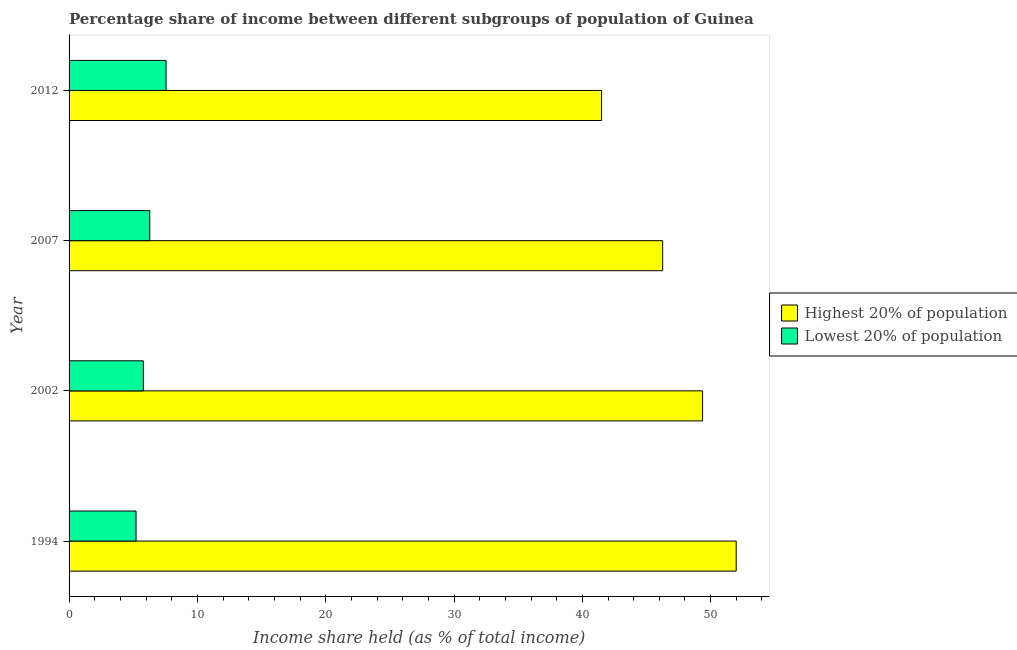How many groups of bars are there?
Ensure brevity in your answer.  4. Are the number of bars per tick equal to the number of legend labels?
Ensure brevity in your answer.  Yes. How many bars are there on the 1st tick from the top?
Make the answer very short. 2. What is the income share held by lowest 20% of the population in 2002?
Keep it short and to the point. 5.79. Across all years, what is the maximum income share held by lowest 20% of the population?
Provide a short and direct response. 7.56. Across all years, what is the minimum income share held by lowest 20% of the population?
Offer a terse response. 5.22. In which year was the income share held by highest 20% of the population minimum?
Offer a terse response. 2012. What is the total income share held by highest 20% of the population in the graph?
Your answer should be compact. 189.12. What is the difference between the income share held by highest 20% of the population in 2007 and that in 2012?
Your answer should be compact. 4.76. What is the difference between the income share held by highest 20% of the population in 2002 and the income share held by lowest 20% of the population in 1994?
Provide a succinct answer. 44.15. What is the average income share held by lowest 20% of the population per year?
Give a very brief answer. 6.21. In the year 1994, what is the difference between the income share held by highest 20% of the population and income share held by lowest 20% of the population?
Offer a very short reply. 46.77. In how many years, is the income share held by highest 20% of the population greater than 48 %?
Provide a succinct answer. 2. What is the ratio of the income share held by highest 20% of the population in 1994 to that in 2002?
Offer a terse response. 1.05. Is the difference between the income share held by lowest 20% of the population in 2007 and 2012 greater than the difference between the income share held by highest 20% of the population in 2007 and 2012?
Give a very brief answer. No. What is the difference between the highest and the second highest income share held by lowest 20% of the population?
Offer a terse response. 1.27. What is the difference between the highest and the lowest income share held by lowest 20% of the population?
Provide a succinct answer. 2.34. In how many years, is the income share held by highest 20% of the population greater than the average income share held by highest 20% of the population taken over all years?
Ensure brevity in your answer.  2. What does the 1st bar from the top in 2007 represents?
Make the answer very short. Lowest 20% of population. What does the 1st bar from the bottom in 2002 represents?
Offer a very short reply. Highest 20% of population. How many bars are there?
Your response must be concise. 8. How many years are there in the graph?
Give a very brief answer. 4. Are the values on the major ticks of X-axis written in scientific E-notation?
Provide a succinct answer. No. Does the graph contain grids?
Keep it short and to the point. No. Where does the legend appear in the graph?
Ensure brevity in your answer.  Center right. How many legend labels are there?
Keep it short and to the point. 2. How are the legend labels stacked?
Give a very brief answer. Vertical. What is the title of the graph?
Provide a succinct answer. Percentage share of income between different subgroups of population of Guinea. Does "Female population" appear as one of the legend labels in the graph?
Provide a succinct answer. No. What is the label or title of the X-axis?
Your answer should be very brief. Income share held (as % of total income). What is the label or title of the Y-axis?
Provide a short and direct response. Year. What is the Income share held (as % of total income) of Highest 20% of population in 1994?
Keep it short and to the point. 51.99. What is the Income share held (as % of total income) in Lowest 20% of population in 1994?
Your answer should be very brief. 5.22. What is the Income share held (as % of total income) in Highest 20% of population in 2002?
Give a very brief answer. 49.37. What is the Income share held (as % of total income) of Lowest 20% of population in 2002?
Your answer should be very brief. 5.79. What is the Income share held (as % of total income) in Highest 20% of population in 2007?
Your response must be concise. 46.26. What is the Income share held (as % of total income) in Lowest 20% of population in 2007?
Your response must be concise. 6.29. What is the Income share held (as % of total income) of Highest 20% of population in 2012?
Provide a short and direct response. 41.5. What is the Income share held (as % of total income) in Lowest 20% of population in 2012?
Offer a very short reply. 7.56. Across all years, what is the maximum Income share held (as % of total income) in Highest 20% of population?
Offer a very short reply. 51.99. Across all years, what is the maximum Income share held (as % of total income) in Lowest 20% of population?
Make the answer very short. 7.56. Across all years, what is the minimum Income share held (as % of total income) in Highest 20% of population?
Offer a terse response. 41.5. Across all years, what is the minimum Income share held (as % of total income) of Lowest 20% of population?
Provide a succinct answer. 5.22. What is the total Income share held (as % of total income) in Highest 20% of population in the graph?
Your answer should be very brief. 189.12. What is the total Income share held (as % of total income) of Lowest 20% of population in the graph?
Your answer should be compact. 24.86. What is the difference between the Income share held (as % of total income) of Highest 20% of population in 1994 and that in 2002?
Offer a very short reply. 2.62. What is the difference between the Income share held (as % of total income) of Lowest 20% of population in 1994 and that in 2002?
Ensure brevity in your answer.  -0.57. What is the difference between the Income share held (as % of total income) in Highest 20% of population in 1994 and that in 2007?
Your response must be concise. 5.73. What is the difference between the Income share held (as % of total income) of Lowest 20% of population in 1994 and that in 2007?
Ensure brevity in your answer.  -1.07. What is the difference between the Income share held (as % of total income) in Highest 20% of population in 1994 and that in 2012?
Offer a very short reply. 10.49. What is the difference between the Income share held (as % of total income) of Lowest 20% of population in 1994 and that in 2012?
Make the answer very short. -2.34. What is the difference between the Income share held (as % of total income) in Highest 20% of population in 2002 and that in 2007?
Make the answer very short. 3.11. What is the difference between the Income share held (as % of total income) of Highest 20% of population in 2002 and that in 2012?
Your answer should be compact. 7.87. What is the difference between the Income share held (as % of total income) in Lowest 20% of population in 2002 and that in 2012?
Offer a very short reply. -1.77. What is the difference between the Income share held (as % of total income) in Highest 20% of population in 2007 and that in 2012?
Your answer should be compact. 4.76. What is the difference between the Income share held (as % of total income) in Lowest 20% of population in 2007 and that in 2012?
Offer a terse response. -1.27. What is the difference between the Income share held (as % of total income) of Highest 20% of population in 1994 and the Income share held (as % of total income) of Lowest 20% of population in 2002?
Give a very brief answer. 46.2. What is the difference between the Income share held (as % of total income) of Highest 20% of population in 1994 and the Income share held (as % of total income) of Lowest 20% of population in 2007?
Your answer should be very brief. 45.7. What is the difference between the Income share held (as % of total income) of Highest 20% of population in 1994 and the Income share held (as % of total income) of Lowest 20% of population in 2012?
Keep it short and to the point. 44.43. What is the difference between the Income share held (as % of total income) of Highest 20% of population in 2002 and the Income share held (as % of total income) of Lowest 20% of population in 2007?
Your answer should be very brief. 43.08. What is the difference between the Income share held (as % of total income) of Highest 20% of population in 2002 and the Income share held (as % of total income) of Lowest 20% of population in 2012?
Provide a succinct answer. 41.81. What is the difference between the Income share held (as % of total income) of Highest 20% of population in 2007 and the Income share held (as % of total income) of Lowest 20% of population in 2012?
Keep it short and to the point. 38.7. What is the average Income share held (as % of total income) of Highest 20% of population per year?
Your answer should be very brief. 47.28. What is the average Income share held (as % of total income) in Lowest 20% of population per year?
Offer a very short reply. 6.21. In the year 1994, what is the difference between the Income share held (as % of total income) of Highest 20% of population and Income share held (as % of total income) of Lowest 20% of population?
Your answer should be very brief. 46.77. In the year 2002, what is the difference between the Income share held (as % of total income) of Highest 20% of population and Income share held (as % of total income) of Lowest 20% of population?
Offer a terse response. 43.58. In the year 2007, what is the difference between the Income share held (as % of total income) in Highest 20% of population and Income share held (as % of total income) in Lowest 20% of population?
Provide a short and direct response. 39.97. In the year 2012, what is the difference between the Income share held (as % of total income) in Highest 20% of population and Income share held (as % of total income) in Lowest 20% of population?
Provide a succinct answer. 33.94. What is the ratio of the Income share held (as % of total income) in Highest 20% of population in 1994 to that in 2002?
Make the answer very short. 1.05. What is the ratio of the Income share held (as % of total income) in Lowest 20% of population in 1994 to that in 2002?
Your answer should be compact. 0.9. What is the ratio of the Income share held (as % of total income) of Highest 20% of population in 1994 to that in 2007?
Offer a very short reply. 1.12. What is the ratio of the Income share held (as % of total income) in Lowest 20% of population in 1994 to that in 2007?
Provide a succinct answer. 0.83. What is the ratio of the Income share held (as % of total income) in Highest 20% of population in 1994 to that in 2012?
Keep it short and to the point. 1.25. What is the ratio of the Income share held (as % of total income) of Lowest 20% of population in 1994 to that in 2012?
Offer a very short reply. 0.69. What is the ratio of the Income share held (as % of total income) in Highest 20% of population in 2002 to that in 2007?
Give a very brief answer. 1.07. What is the ratio of the Income share held (as % of total income) in Lowest 20% of population in 2002 to that in 2007?
Your answer should be compact. 0.92. What is the ratio of the Income share held (as % of total income) in Highest 20% of population in 2002 to that in 2012?
Provide a succinct answer. 1.19. What is the ratio of the Income share held (as % of total income) in Lowest 20% of population in 2002 to that in 2012?
Make the answer very short. 0.77. What is the ratio of the Income share held (as % of total income) of Highest 20% of population in 2007 to that in 2012?
Your response must be concise. 1.11. What is the ratio of the Income share held (as % of total income) of Lowest 20% of population in 2007 to that in 2012?
Your answer should be compact. 0.83. What is the difference between the highest and the second highest Income share held (as % of total income) in Highest 20% of population?
Provide a short and direct response. 2.62. What is the difference between the highest and the second highest Income share held (as % of total income) in Lowest 20% of population?
Ensure brevity in your answer.  1.27. What is the difference between the highest and the lowest Income share held (as % of total income) of Highest 20% of population?
Your answer should be compact. 10.49. What is the difference between the highest and the lowest Income share held (as % of total income) of Lowest 20% of population?
Ensure brevity in your answer.  2.34. 